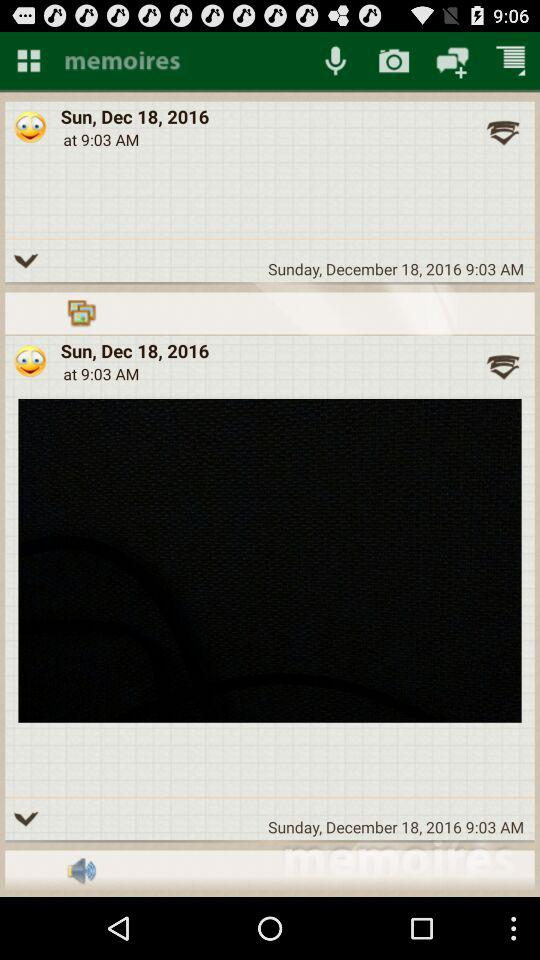What 's the time? The time is 9:03 AM. 